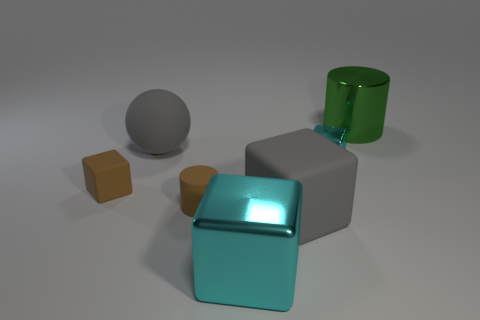What material is the green object?
Offer a very short reply. Metal. What is the size of the gray object that is made of the same material as the big gray block?
Offer a very short reply. Large. There is a metal cube behind the small cylinder; what number of metallic objects are right of it?
Your response must be concise. 1. Do the tiny cube that is right of the small cylinder and the big cyan object have the same material?
Your answer should be very brief. Yes. There is a cyan metal cube that is in front of the big gray matte thing to the right of the large cyan metallic block; what size is it?
Your answer should be compact. Large. How big is the matte cube to the left of the gray matte object on the right side of the large gray object behind the brown cylinder?
Your response must be concise. Small. There is a cyan metal thing that is to the left of the large rubber cube; is its shape the same as the big gray matte object to the left of the big cyan object?
Your answer should be very brief. No. What number of other things are the same color as the small rubber block?
Make the answer very short. 1. There is a cylinder that is in front of the green metallic cylinder; is its size the same as the tiny metallic object?
Keep it short and to the point. Yes. Does the tiny cube that is to the left of the gray rubber sphere have the same material as the cyan object behind the small brown rubber cylinder?
Ensure brevity in your answer.  No. 